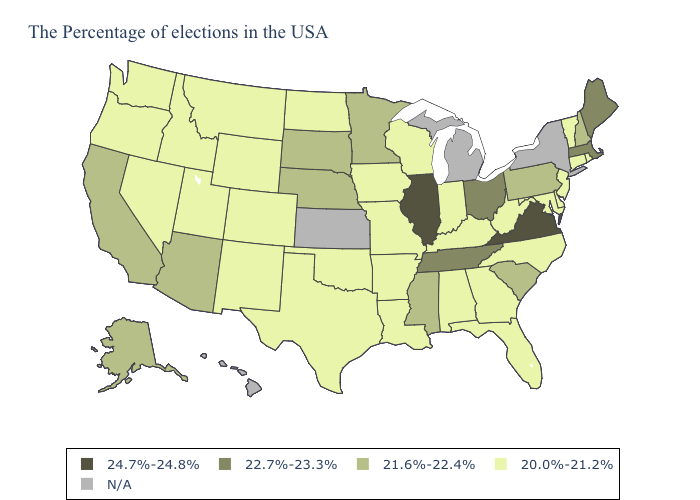What is the lowest value in the USA?
Concise answer only. 20.0%-21.2%. Among the states that border Georgia , which have the highest value?
Keep it brief. Tennessee. Among the states that border Louisiana , which have the lowest value?
Concise answer only. Arkansas, Texas. Name the states that have a value in the range N/A?
Concise answer only. New York, Michigan, Kansas, Hawaii. Name the states that have a value in the range 21.6%-22.4%?
Be succinct. New Hampshire, Pennsylvania, South Carolina, Mississippi, Minnesota, Nebraska, South Dakota, Arizona, California, Alaska. What is the value of Missouri?
Concise answer only. 20.0%-21.2%. What is the value of New York?
Keep it brief. N/A. Does the first symbol in the legend represent the smallest category?
Concise answer only. No. Among the states that border Florida , which have the lowest value?
Concise answer only. Georgia, Alabama. Which states have the lowest value in the USA?
Write a very short answer. Rhode Island, Vermont, Connecticut, New Jersey, Delaware, Maryland, North Carolina, West Virginia, Florida, Georgia, Kentucky, Indiana, Alabama, Wisconsin, Louisiana, Missouri, Arkansas, Iowa, Oklahoma, Texas, North Dakota, Wyoming, Colorado, New Mexico, Utah, Montana, Idaho, Nevada, Washington, Oregon. Name the states that have a value in the range 21.6%-22.4%?
Answer briefly. New Hampshire, Pennsylvania, South Carolina, Mississippi, Minnesota, Nebraska, South Dakota, Arizona, California, Alaska. What is the lowest value in the MidWest?
Be succinct. 20.0%-21.2%. What is the value of Nevada?
Short answer required. 20.0%-21.2%. 